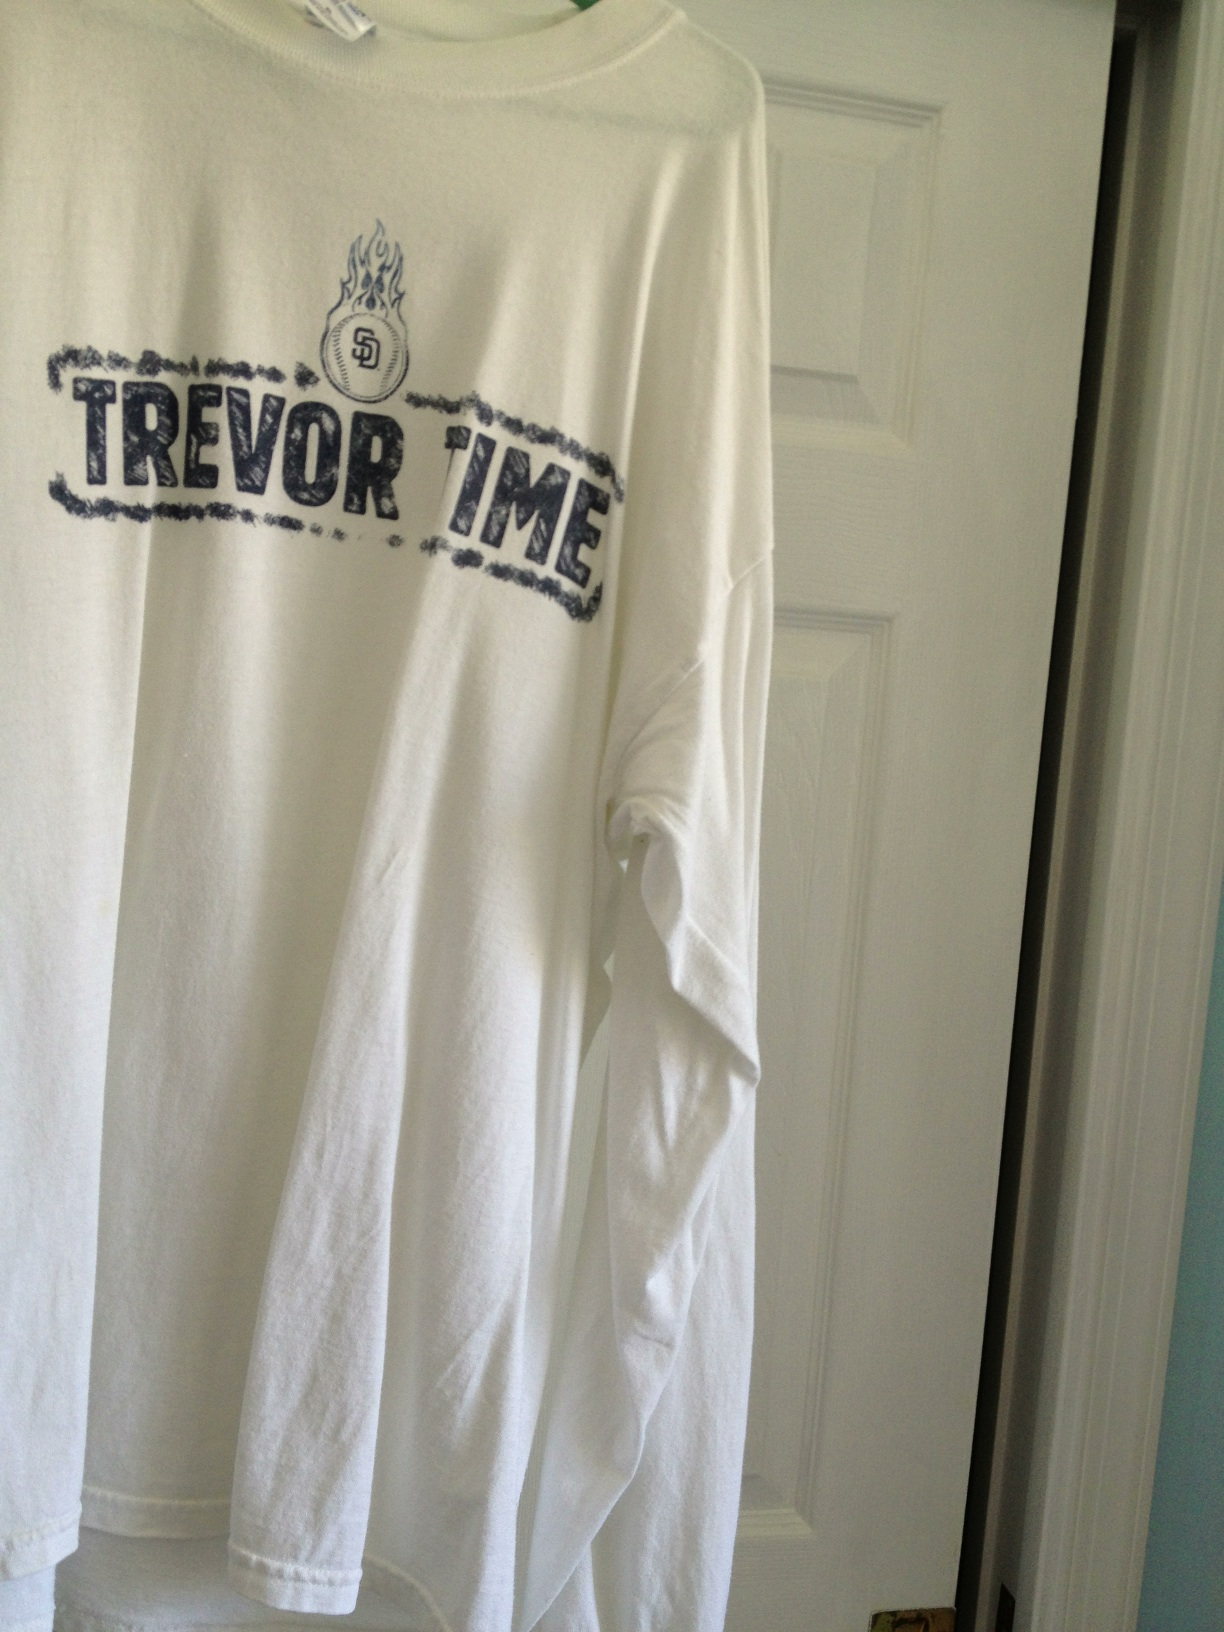Imagine a wild scenario involving this shirt. One day, while examining this very shirt, an avid fan discovered an old map hidden within the seams. Little did they know, this map led to a treasure trove of historic San Diego Padres memorabilia hidden deep beneath the stadium, guarded by a series of baseball-themed puzzles and challenges. The fan, equipped with their love for the team and this newfound map, embarked on a thrilling adventure to uncover the hidden treasures of their beloved team. 